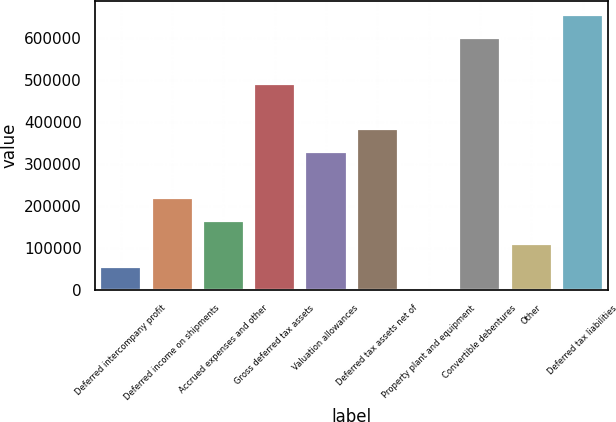Convert chart. <chart><loc_0><loc_0><loc_500><loc_500><bar_chart><fcel>Deferred intercompany profit<fcel>Deferred income on shipments<fcel>Accrued expenses and other<fcel>Gross deferred tax assets<fcel>Valuation allowances<fcel>Deferred tax assets net of<fcel>Property plant and equipment<fcel>Convertible debentures<fcel>Other<fcel>Deferred tax liabilities<nl><fcel>56349.8<fcel>219573<fcel>165165<fcel>491612<fcel>328389<fcel>382797<fcel>1942<fcel>600428<fcel>110758<fcel>654836<nl></chart> 